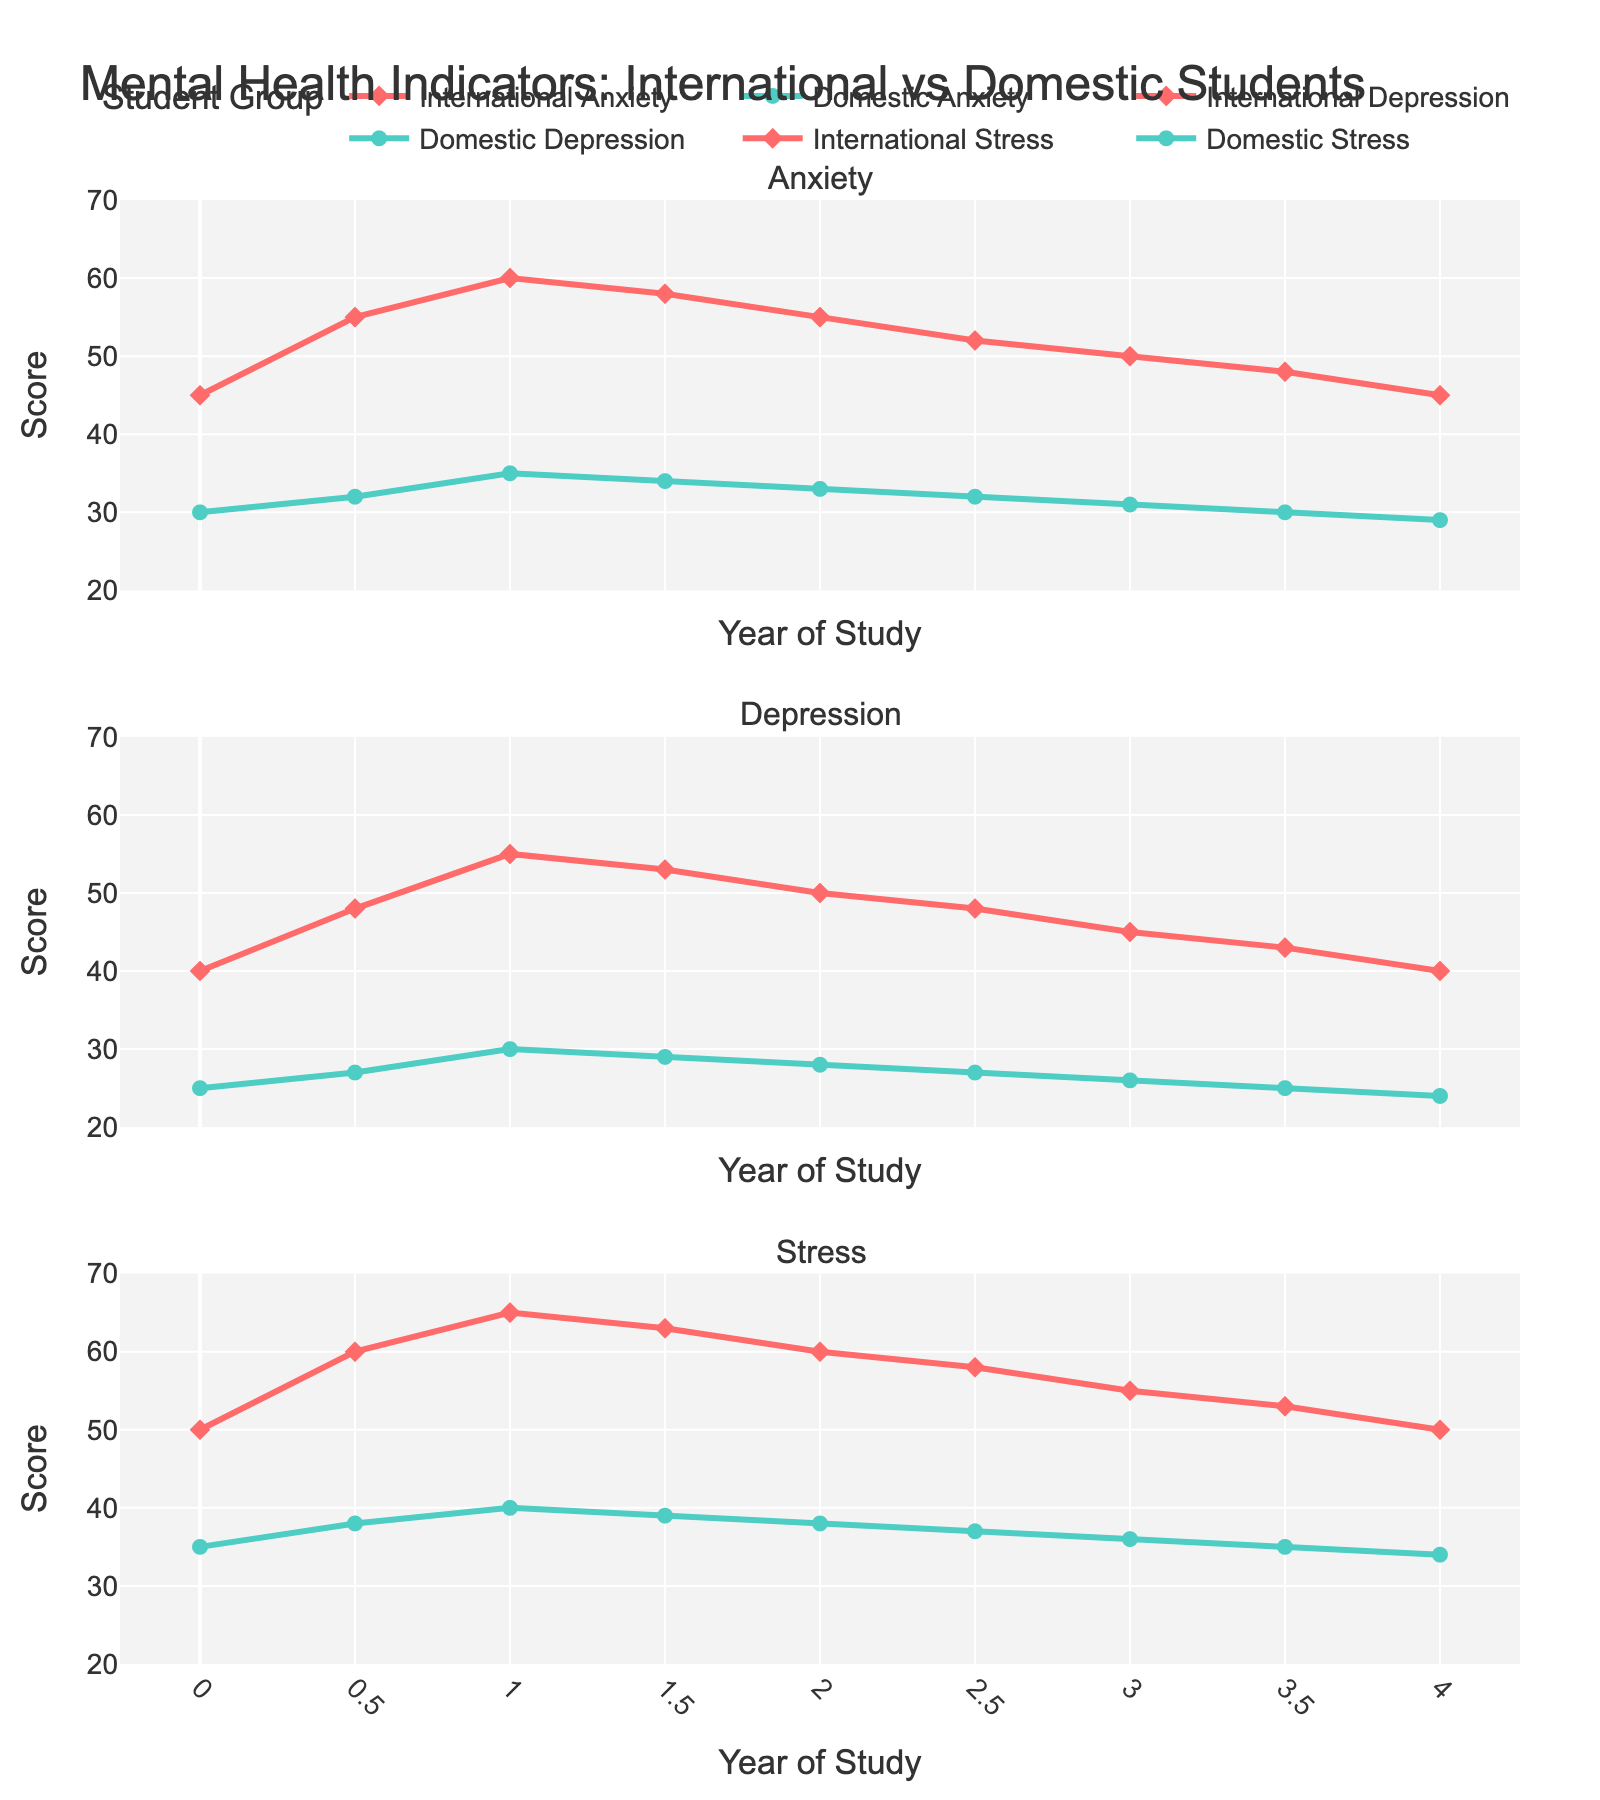What's the difference in anxiety levels between international and domestic students at the beginning (Year 0) and at the end (Year 4)? First, note the anxiety levels at Year 0: International students have 45, and Domestic students have 30. The difference is 45 - 30 = 15. At Year 4: International students have 45, and Domestic students have 29. The difference is 45 - 29 = 16.
Answer: 15, 16 Which group has the highest peak in depression scores, and what is that score? Looking at the plot, the highest peak for international students in depression appears at Year 1 with a score of 55. For domestic students, the highest peak is at Year 1 with a score of 30. Therefore, the highest peak is for international students with a score of 55.
Answer: International students, 55 At which year do international students experience the highest stress level, and what is that level? From the plot, the highest stress level for international students is at Year 1 with a score of 65.
Answer: Year 1, 65 What is the average depression score for domestic students throughout the academic years? Sum the depression scores for domestic students: 25 + 27 + 30 + 29 + 28 + 27 + 26 + 25 + 24 = 241. Divide by the number of years (9). So, 241 / 9 ≈ 26.78.
Answer: 26.78 Which metric shows the smallest difference between international and domestic students at Year 2.5? At Year 2.5, compare the differences: Anxiety: 52 - 32 = 20, Depression: 48 - 27 = 21, Stress: 58 - 37 = 21. The smallest difference is in Anxiety (20).
Answer: Anxiety How do anxiety levels evolve for both groups over the four academic years? For international students, anxiety rises from 45 to a peak of 60 at Year 1, then gradually declines back to 45 at Year 4. Domestic students' anxiety rises slightly from 30 to 35 by Year 1, then steadily decreases to 29 by Year 4.
Answer: International: rises then declines, Domestic: slight rise then decline In which metric and at which year do international and domestic students have the closest score? The closest scores in all metrics appear very near Year 4 for Anxiety. Both international and domestic students have scores almost the same: 45 for international and 29 for domestic. Therefore, Anxiety at Year 4 is the closest.
Answer: Anxiety, Year 4 What is the trend in stress levels for both groups from Year 0 to Year 4? International students' stress levels rise from 50 to 65 by Year 1 and then gradually decrease to 50 by Year 4. Domestic students' stress levels rise from 35 to 40 by Year 1 and then gradually decrease to 34 by Year 4.
Answer: International: rise then fall, Domestic: rise then fall 